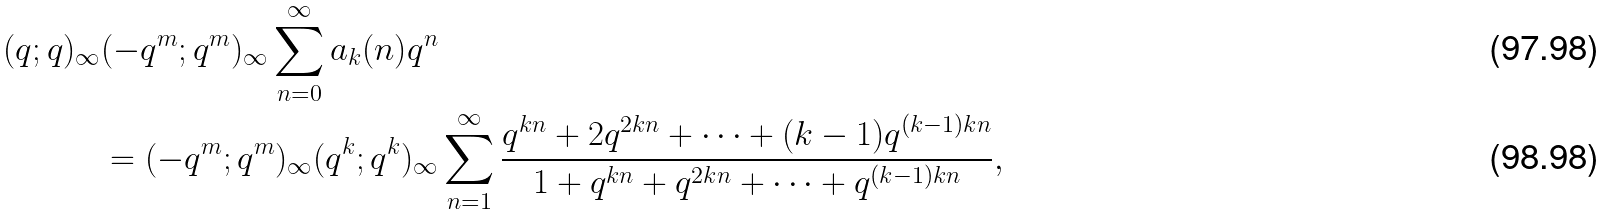<formula> <loc_0><loc_0><loc_500><loc_500>( q ; q ) _ { \infty } & ( - q ^ { m } ; q ^ { m } ) _ { \infty } \sum _ { n = 0 } ^ { \infty } a _ { k } ( n ) q ^ { n } \\ & = ( - q ^ { m } ; q ^ { m } ) _ { \infty } ( q ^ { k } ; q ^ { k } ) _ { \infty } \sum _ { n = 1 } ^ { \infty } \frac { q ^ { k n } + 2 q ^ { 2 k n } + \dots + ( k - 1 ) q ^ { ( k - 1 ) k n } } { 1 + q ^ { k n } + q ^ { 2 k n } + \dots + q ^ { ( k - 1 ) k n } } ,</formula> 